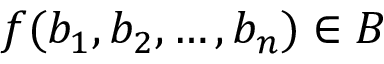<formula> <loc_0><loc_0><loc_500><loc_500>f ( b _ { 1 } , b _ { 2 } , \dots , b _ { n } ) \in B</formula> 